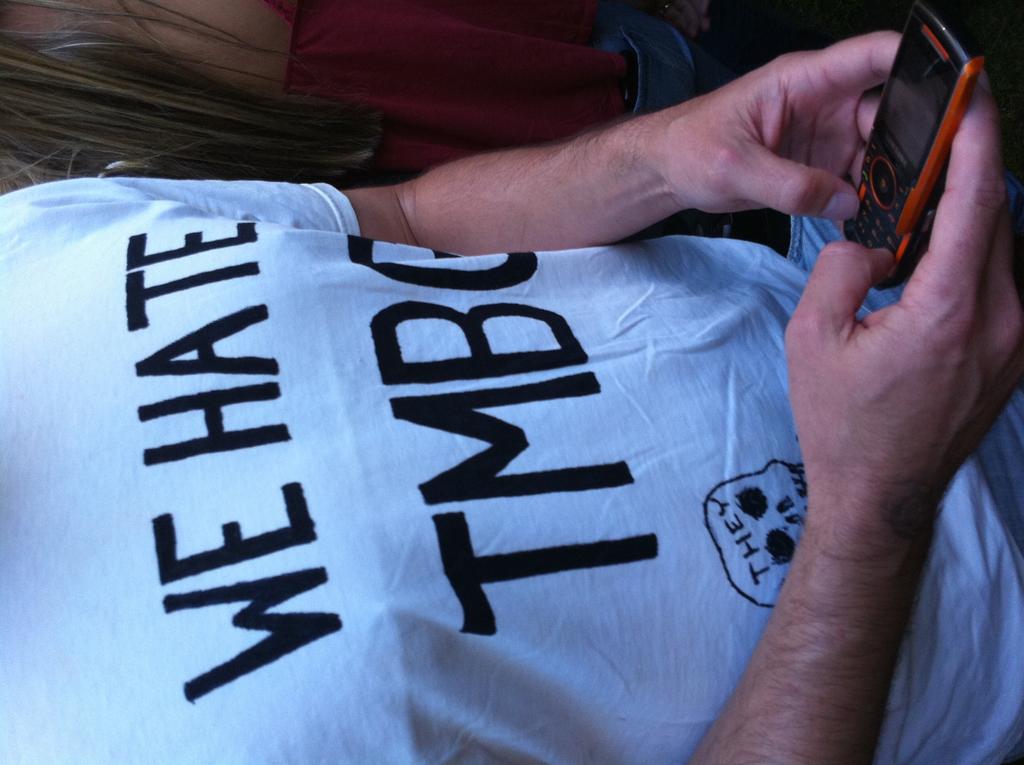What is written on the head of the skull on the shirt?
Ensure brevity in your answer.  They. What are the top two words on this shirt?
Ensure brevity in your answer.  We hate. 